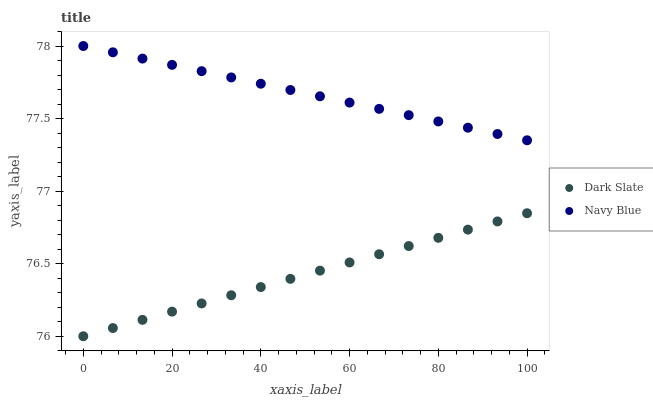Does Dark Slate have the minimum area under the curve?
Answer yes or no. Yes. Does Navy Blue have the maximum area under the curve?
Answer yes or no. Yes. Does Navy Blue have the minimum area under the curve?
Answer yes or no. No. Is Dark Slate the smoothest?
Answer yes or no. Yes. Is Navy Blue the roughest?
Answer yes or no. Yes. Is Navy Blue the smoothest?
Answer yes or no. No. Does Dark Slate have the lowest value?
Answer yes or no. Yes. Does Navy Blue have the lowest value?
Answer yes or no. No. Does Navy Blue have the highest value?
Answer yes or no. Yes. Is Dark Slate less than Navy Blue?
Answer yes or no. Yes. Is Navy Blue greater than Dark Slate?
Answer yes or no. Yes. Does Dark Slate intersect Navy Blue?
Answer yes or no. No. 